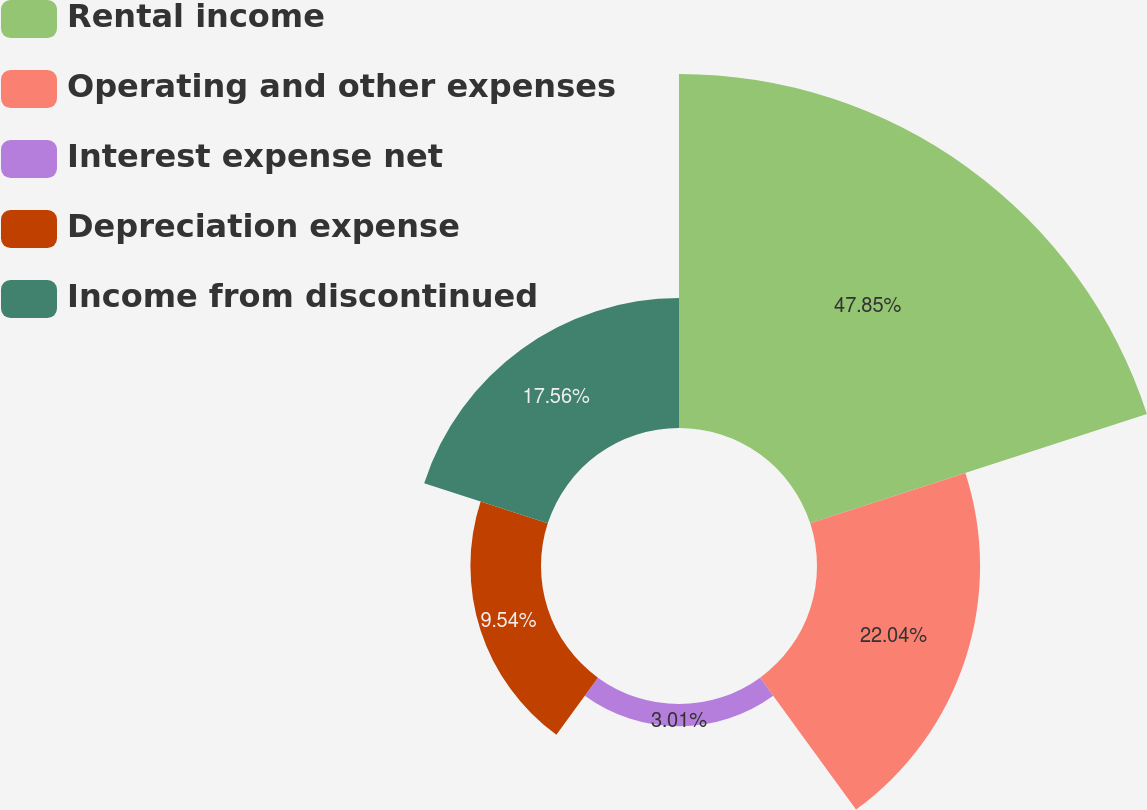Convert chart to OTSL. <chart><loc_0><loc_0><loc_500><loc_500><pie_chart><fcel>Rental income<fcel>Operating and other expenses<fcel>Interest expense net<fcel>Depreciation expense<fcel>Income from discontinued<nl><fcel>47.84%<fcel>22.04%<fcel>3.01%<fcel>9.54%<fcel>17.56%<nl></chart> 